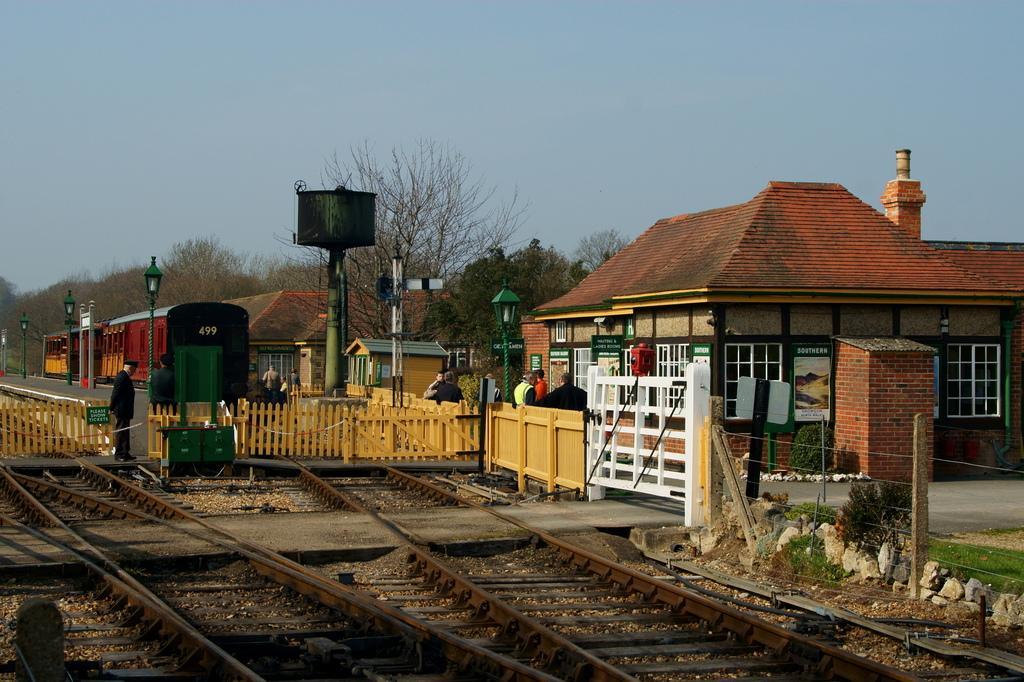Describe this image in one or two sentences. In this image we can see railway track, fencing and a gate. Behind the fencing we can see a group of trees, persons, houses and poles with lights. At the top we can see the sky. On the right side of the image we can see few plants. 